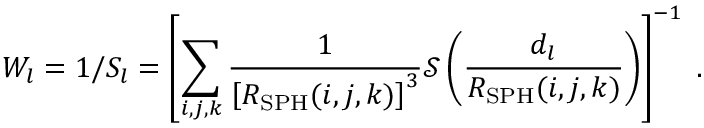<formula> <loc_0><loc_0><loc_500><loc_500>W _ { l } = 1 / S _ { l } = \left [ \sum _ { i , j , k } \frac { 1 } { \left [ R _ { S P H } ( i , j , k ) \right ] ^ { 3 } } \mathcal { S } \left ( \frac { d _ { l } } { R _ { S P H } ( i , j , k ) } \right ) \right ] ^ { - 1 } \, .</formula> 